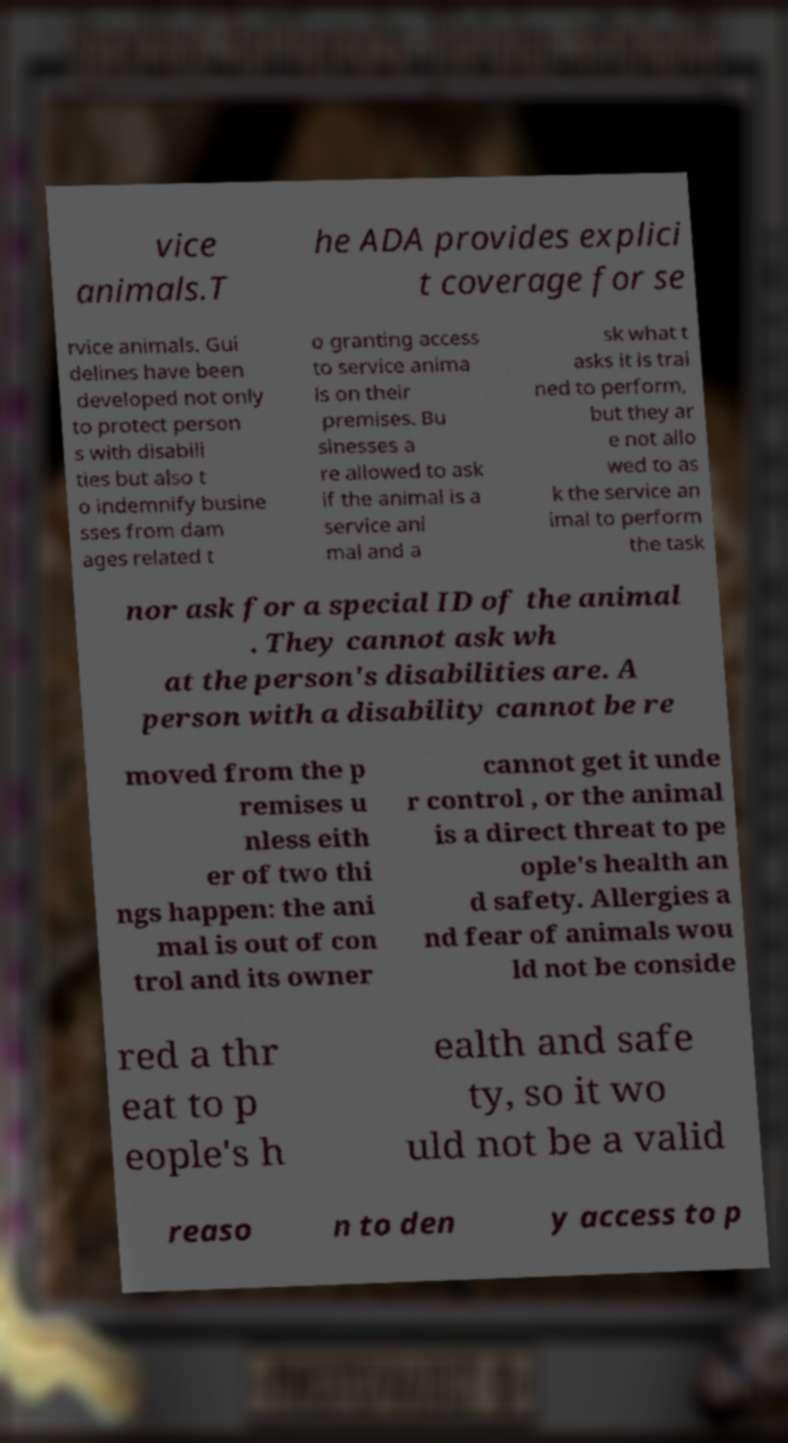Can you read and provide the text displayed in the image?This photo seems to have some interesting text. Can you extract and type it out for me? vice animals.T he ADA provides explici t coverage for se rvice animals. Gui delines have been developed not only to protect person s with disabili ties but also t o indemnify busine sses from dam ages related t o granting access to service anima ls on their premises. Bu sinesses a re allowed to ask if the animal is a service ani mal and a sk what t asks it is trai ned to perform, but they ar e not allo wed to as k the service an imal to perform the task nor ask for a special ID of the animal . They cannot ask wh at the person's disabilities are. A person with a disability cannot be re moved from the p remises u nless eith er of two thi ngs happen: the ani mal is out of con trol and its owner cannot get it unde r control , or the animal is a direct threat to pe ople's health an d safety. Allergies a nd fear of animals wou ld not be conside red a thr eat to p eople's h ealth and safe ty, so it wo uld not be a valid reaso n to den y access to p 